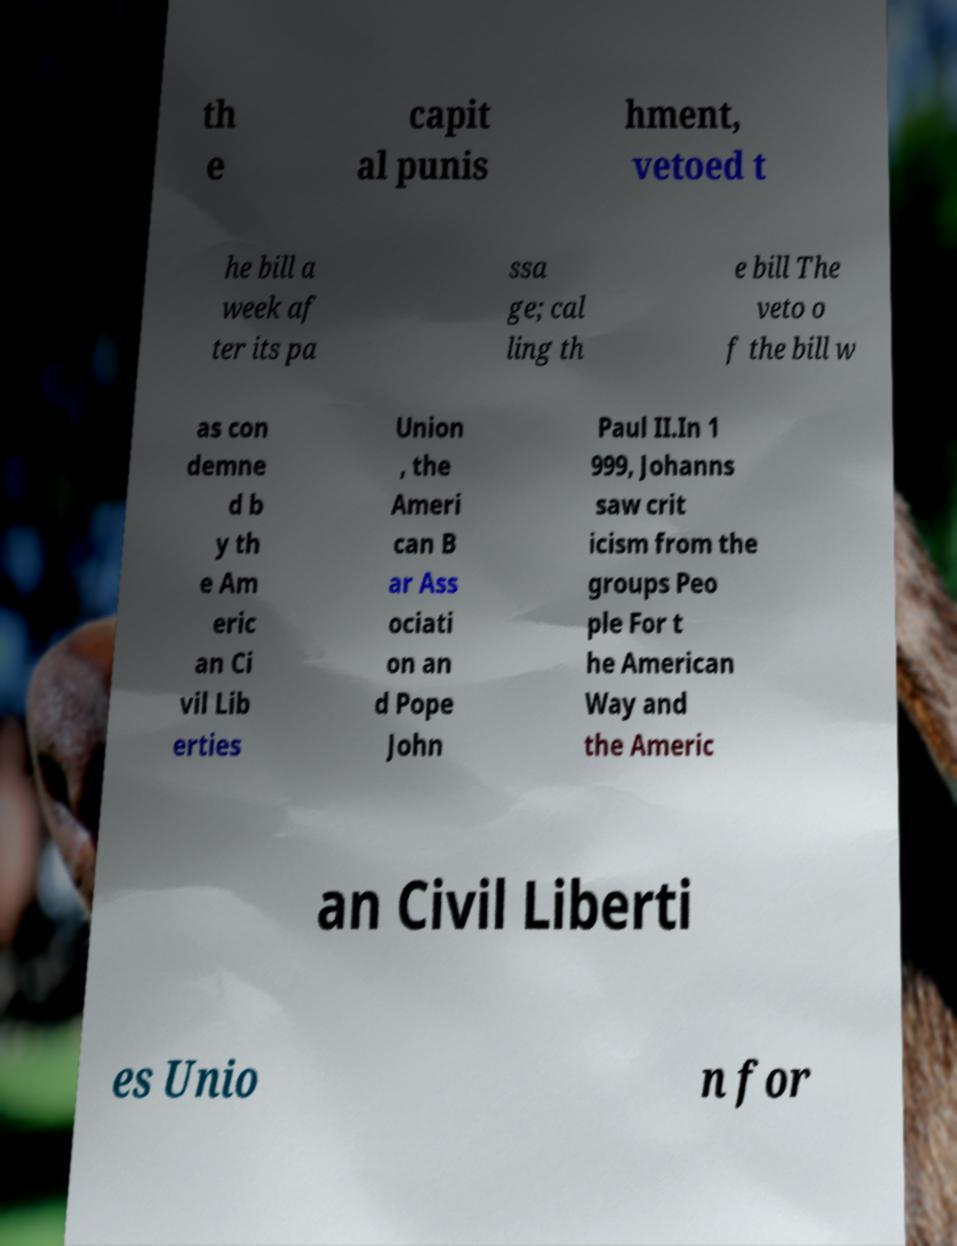For documentation purposes, I need the text within this image transcribed. Could you provide that? th e capit al punis hment, vetoed t he bill a week af ter its pa ssa ge; cal ling th e bill The veto o f the bill w as con demne d b y th e Am eric an Ci vil Lib erties Union , the Ameri can B ar Ass ociati on an d Pope John Paul II.In 1 999, Johanns saw crit icism from the groups Peo ple For t he American Way and the Americ an Civil Liberti es Unio n for 